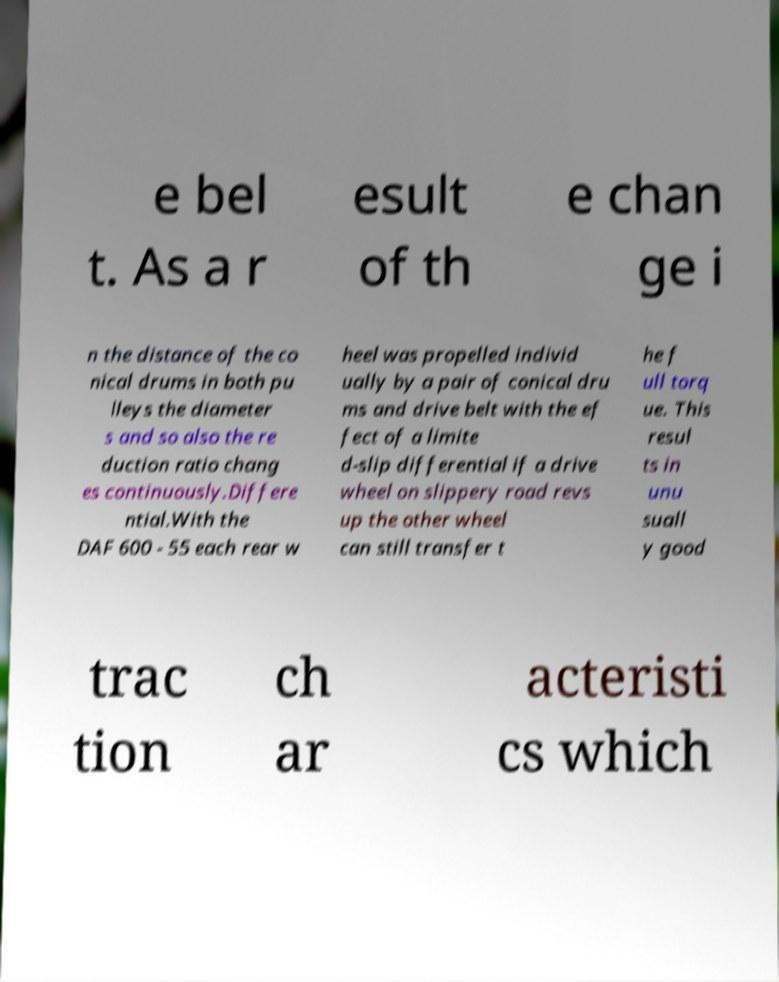Could you extract and type out the text from this image? e bel t. As a r esult of th e chan ge i n the distance of the co nical drums in both pu lleys the diameter s and so also the re duction ratio chang es continuously.Differe ntial.With the DAF 600 - 55 each rear w heel was propelled individ ually by a pair of conical dru ms and drive belt with the ef fect of a limite d-slip differential if a drive wheel on slippery road revs up the other wheel can still transfer t he f ull torq ue. This resul ts in unu suall y good trac tion ch ar acteristi cs which 